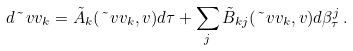<formula> <loc_0><loc_0><loc_500><loc_500>d \tilde { \ } v v _ { k } = \tilde { A } _ { k } ( \tilde { \ } v v _ { k } , v ) d \tau + \sum _ { j } \tilde { B } _ { k j } ( \tilde { \ } v v _ { k } , v ) d \beta ^ { j } _ { \tau } \, .</formula> 